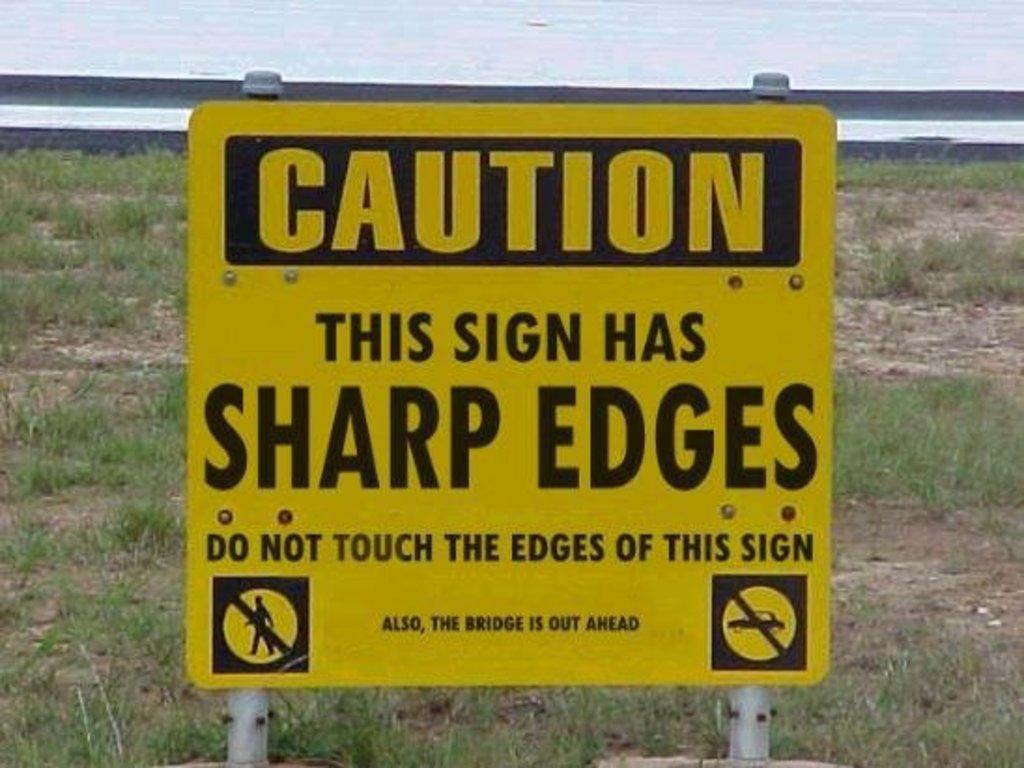<image>
Give a short and clear explanation of the subsequent image. a caution sign that is on the grass outside 